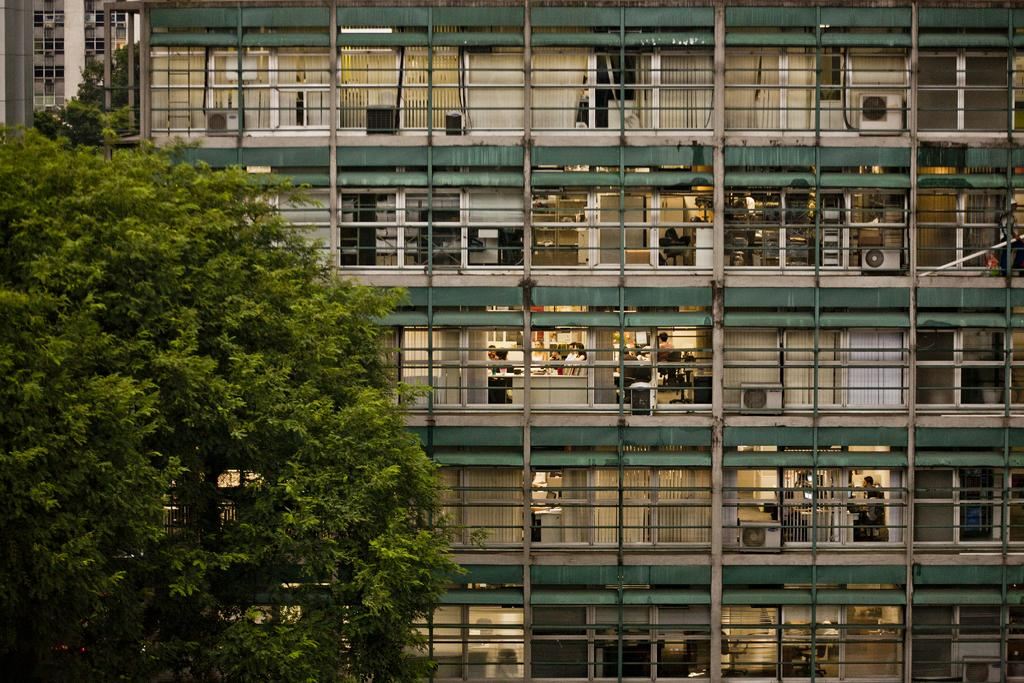What type of vegetation is on the left side of the image? There are trees on the left side of the image. What structure is located in the middle of the image? There is a building in the middle of the image. Can you describe the people visible in the building? Unfortunately, the image does not provide enough detail to describe the people visible in the building. What type of clam is crawling on the building in the image? There is no clam present in the image; it features trees on the left side and a building in the middle. What type of creature is visible on the roof of the building in the image? There is no creature visible on the roof of the building in the image. 